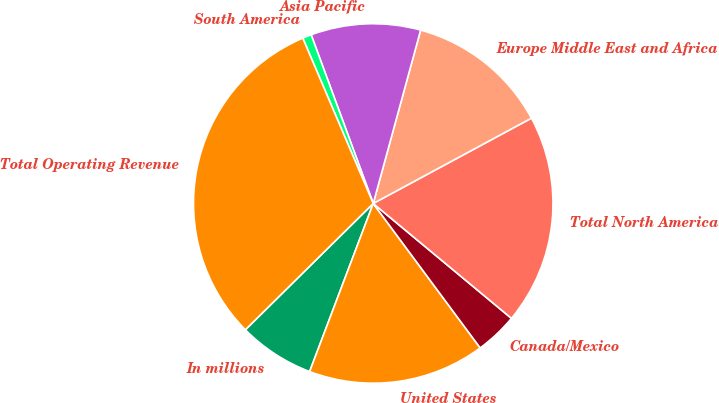Convert chart. <chart><loc_0><loc_0><loc_500><loc_500><pie_chart><fcel>In millions<fcel>United States<fcel>Canada/Mexico<fcel>Total North America<fcel>Europe Middle East and Africa<fcel>Asia Pacific<fcel>South America<fcel>Total Operating Revenue<nl><fcel>6.84%<fcel>15.9%<fcel>3.82%<fcel>18.91%<fcel>12.88%<fcel>9.86%<fcel>0.8%<fcel>30.99%<nl></chart> 